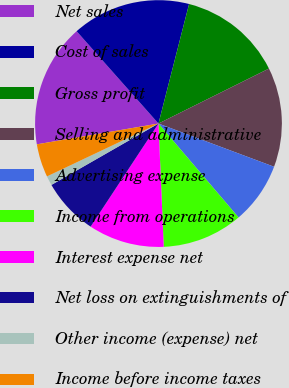Convert chart to OTSL. <chart><loc_0><loc_0><loc_500><loc_500><pie_chart><fcel>Net sales<fcel>Cost of sales<fcel>Gross profit<fcel>Selling and administrative<fcel>Advertising expense<fcel>Income from operations<fcel>Interest expense net<fcel>Net loss on extinguishments of<fcel>Other income (expense) net<fcel>Income before income taxes<nl><fcel>16.15%<fcel>15.53%<fcel>13.66%<fcel>13.04%<fcel>8.07%<fcel>10.56%<fcel>9.94%<fcel>7.45%<fcel>1.24%<fcel>4.35%<nl></chart> 